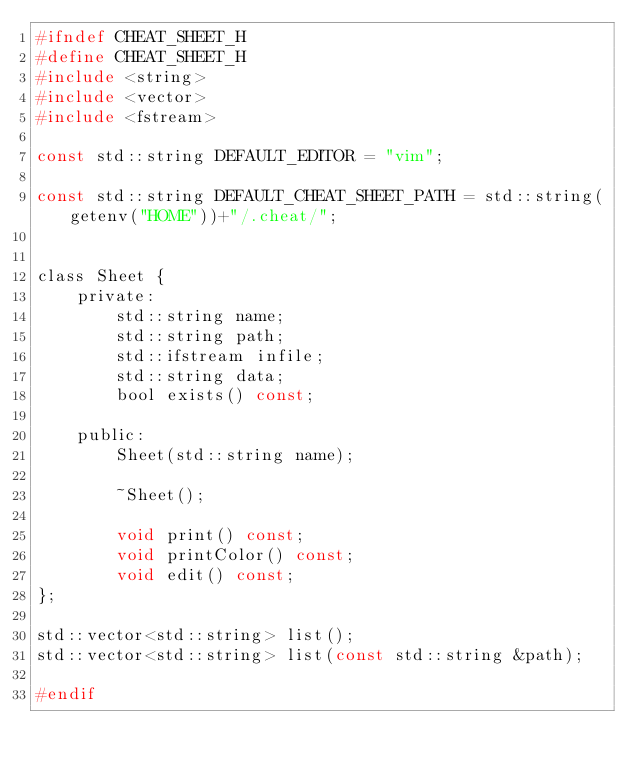Convert code to text. <code><loc_0><loc_0><loc_500><loc_500><_C_>#ifndef CHEAT_SHEET_H
#define CHEAT_SHEET_H
#include <string>
#include <vector>
#include <fstream>

const std::string DEFAULT_EDITOR = "vim";

const std::string DEFAULT_CHEAT_SHEET_PATH = std::string(getenv("HOME"))+"/.cheat/";


class Sheet {
    private:
        std::string name;
        std::string path;
        std::ifstream infile;
        std::string data;
        bool exists() const;

    public:
        Sheet(std::string name);

        ~Sheet();

        void print() const;
        void printColor() const;
        void edit() const;
};

std::vector<std::string> list();
std::vector<std::string> list(const std::string &path);

#endif

</code> 